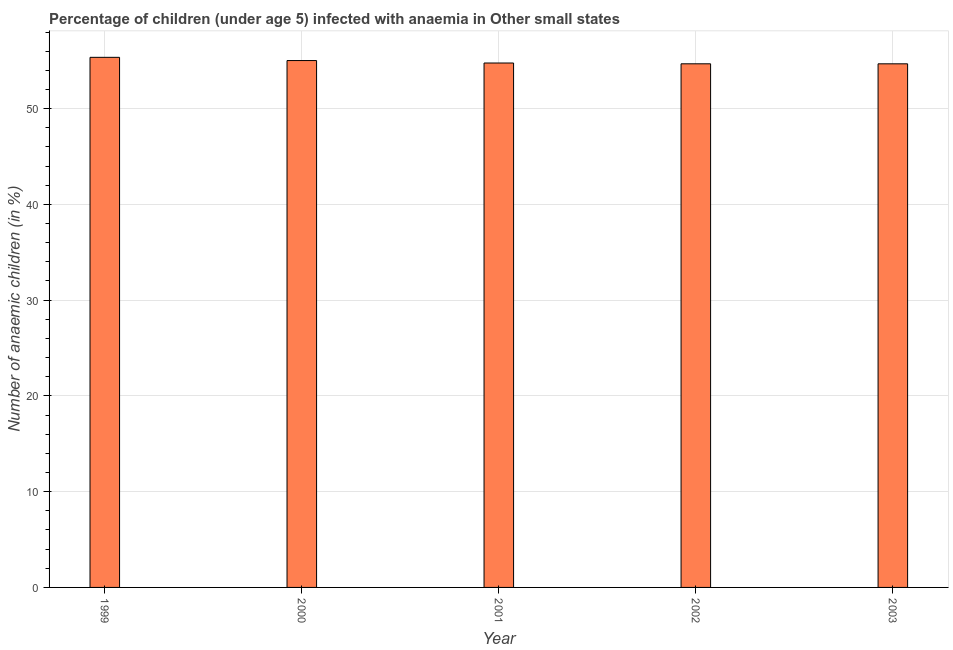Does the graph contain grids?
Your answer should be compact. Yes. What is the title of the graph?
Your answer should be very brief. Percentage of children (under age 5) infected with anaemia in Other small states. What is the label or title of the Y-axis?
Your answer should be very brief. Number of anaemic children (in %). What is the number of anaemic children in 2001?
Offer a very short reply. 54.76. Across all years, what is the maximum number of anaemic children?
Provide a succinct answer. 55.36. Across all years, what is the minimum number of anaemic children?
Offer a very short reply. 54.68. What is the sum of the number of anaemic children?
Offer a very short reply. 274.5. What is the difference between the number of anaemic children in 2000 and 2001?
Your answer should be very brief. 0.26. What is the average number of anaemic children per year?
Keep it short and to the point. 54.9. What is the median number of anaemic children?
Provide a succinct answer. 54.76. In how many years, is the number of anaemic children greater than 12 %?
Keep it short and to the point. 5. Is the difference between the number of anaemic children in 2000 and 2003 greater than the difference between any two years?
Provide a succinct answer. No. What is the difference between the highest and the second highest number of anaemic children?
Offer a terse response. 0.34. Is the sum of the number of anaemic children in 2000 and 2001 greater than the maximum number of anaemic children across all years?
Make the answer very short. Yes. What is the difference between the highest and the lowest number of anaemic children?
Ensure brevity in your answer.  0.68. How many years are there in the graph?
Ensure brevity in your answer.  5. What is the Number of anaemic children (in %) of 1999?
Provide a succinct answer. 55.36. What is the Number of anaemic children (in %) in 2000?
Make the answer very short. 55.02. What is the Number of anaemic children (in %) in 2001?
Offer a very short reply. 54.76. What is the Number of anaemic children (in %) in 2002?
Provide a short and direct response. 54.68. What is the Number of anaemic children (in %) in 2003?
Provide a short and direct response. 54.68. What is the difference between the Number of anaemic children (in %) in 1999 and 2000?
Provide a short and direct response. 0.34. What is the difference between the Number of anaemic children (in %) in 1999 and 2001?
Provide a short and direct response. 0.59. What is the difference between the Number of anaemic children (in %) in 1999 and 2002?
Offer a very short reply. 0.68. What is the difference between the Number of anaemic children (in %) in 1999 and 2003?
Keep it short and to the point. 0.68. What is the difference between the Number of anaemic children (in %) in 2000 and 2001?
Make the answer very short. 0.26. What is the difference between the Number of anaemic children (in %) in 2000 and 2002?
Provide a succinct answer. 0.34. What is the difference between the Number of anaemic children (in %) in 2000 and 2003?
Your answer should be compact. 0.34. What is the difference between the Number of anaemic children (in %) in 2001 and 2002?
Provide a succinct answer. 0.08. What is the difference between the Number of anaemic children (in %) in 2001 and 2003?
Offer a very short reply. 0.08. What is the difference between the Number of anaemic children (in %) in 2002 and 2003?
Provide a short and direct response. 0. What is the ratio of the Number of anaemic children (in %) in 1999 to that in 2000?
Your answer should be compact. 1.01. What is the ratio of the Number of anaemic children (in %) in 2000 to that in 2002?
Offer a terse response. 1.01. What is the ratio of the Number of anaemic children (in %) in 2000 to that in 2003?
Give a very brief answer. 1.01. What is the ratio of the Number of anaemic children (in %) in 2001 to that in 2002?
Your answer should be very brief. 1. What is the ratio of the Number of anaemic children (in %) in 2001 to that in 2003?
Provide a short and direct response. 1. What is the ratio of the Number of anaemic children (in %) in 2002 to that in 2003?
Ensure brevity in your answer.  1. 